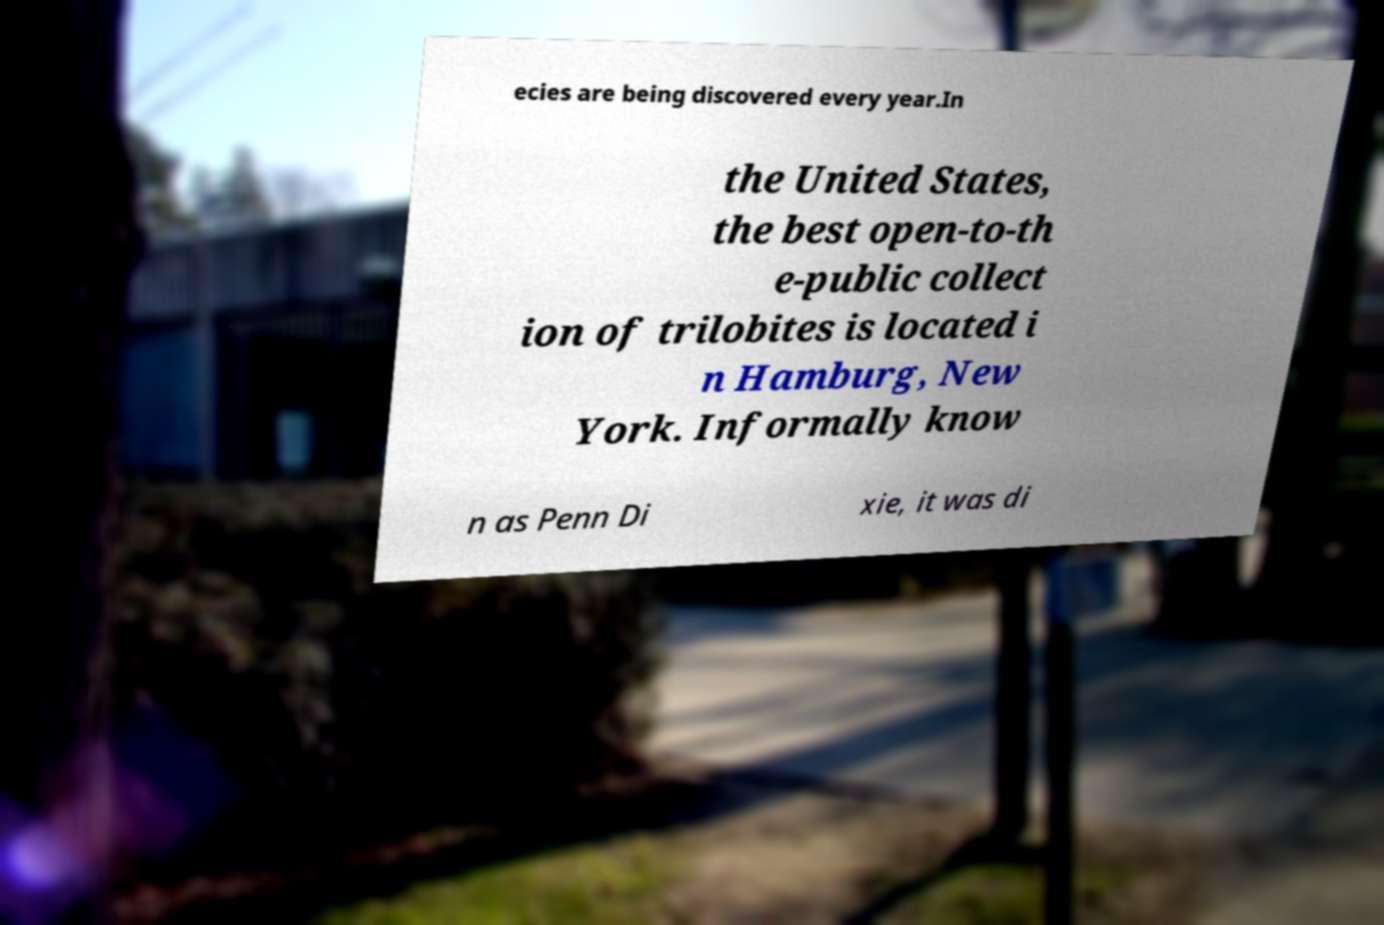Please read and relay the text visible in this image. What does it say? ecies are being discovered every year.In the United States, the best open-to-th e-public collect ion of trilobites is located i n Hamburg, New York. Informally know n as Penn Di xie, it was di 